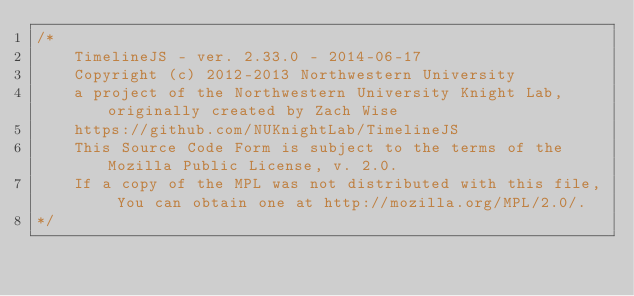Convert code to text. <code><loc_0><loc_0><loc_500><loc_500><_CSS_>/*
    TimelineJS - ver. 2.33.0 - 2014-06-17
    Copyright (c) 2012-2013 Northwestern University
    a project of the Northwestern University Knight Lab, originally created by Zach Wise
    https://github.com/NUKnightLab/TimelineJS
    This Source Code Form is subject to the terms of the Mozilla Public License, v. 2.0.
    If a copy of the MPL was not distributed with this file, You can obtain one at http://mozilla.org/MPL/2.0/.
*/</code> 